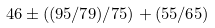Convert formula to latex. <formula><loc_0><loc_0><loc_500><loc_500>4 6 \pm ( ( 9 5 / 7 9 ) / 7 5 ) + ( 5 5 / 6 5 )</formula> 